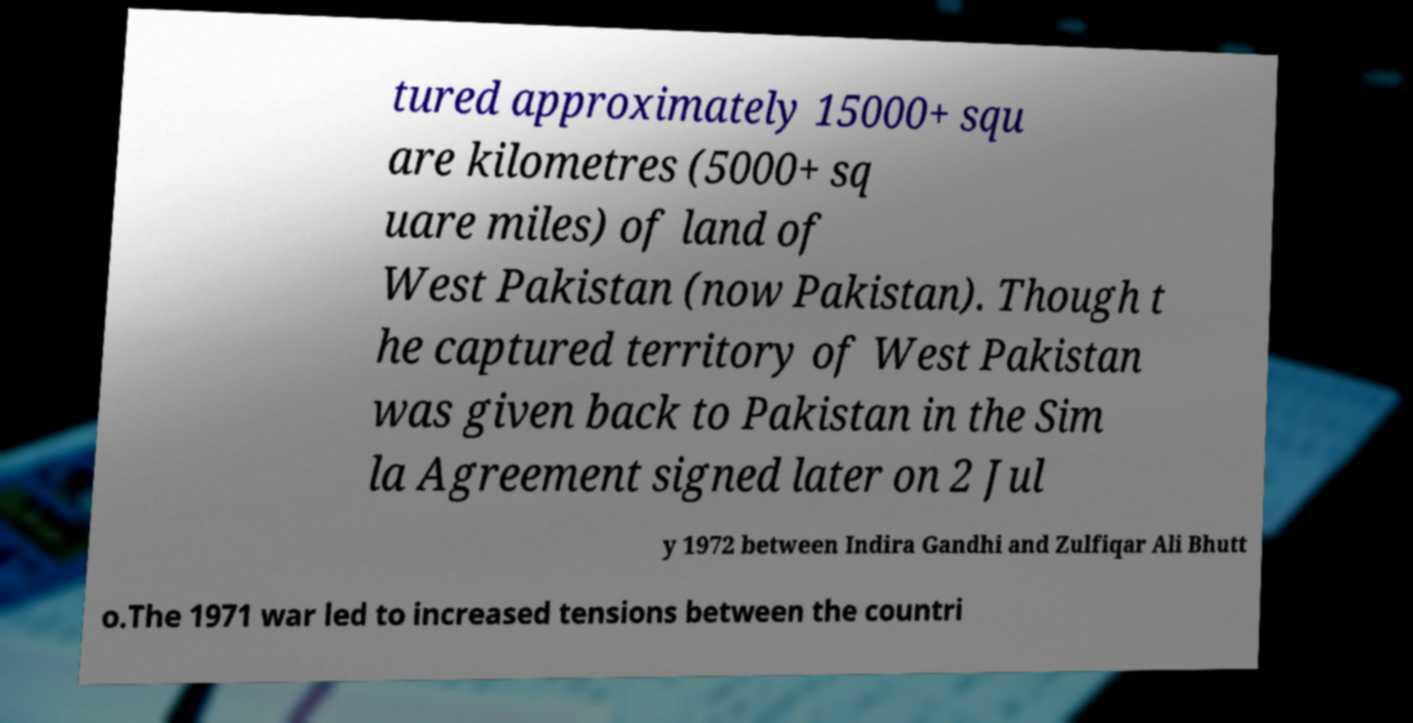Could you assist in decoding the text presented in this image and type it out clearly? tured approximately 15000+ squ are kilometres (5000+ sq uare miles) of land of West Pakistan (now Pakistan). Though t he captured territory of West Pakistan was given back to Pakistan in the Sim la Agreement signed later on 2 Jul y 1972 between Indira Gandhi and Zulfiqar Ali Bhutt o.The 1971 war led to increased tensions between the countri 